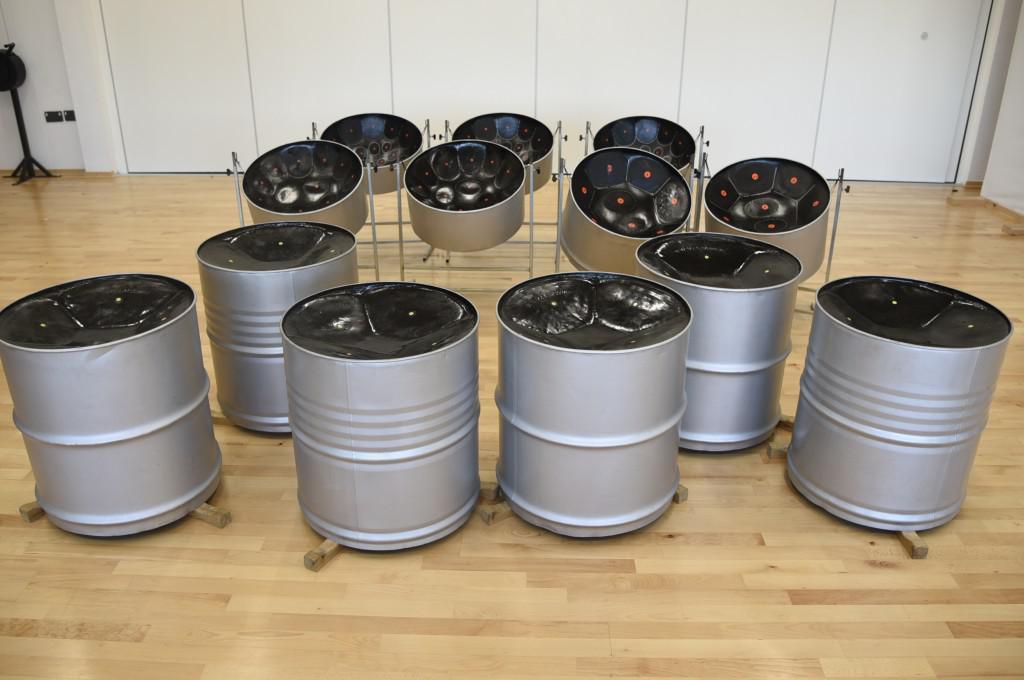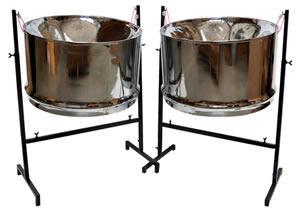The first image is the image on the left, the second image is the image on the right. Given the left and right images, does the statement "One image features a pair of drums wrapped in pale cord, with pillow bases and flat tops with black dots in the center, and the other image is a pair of side-by-side shiny bowl-shaped steel drums." hold true? Answer yes or no. No. The first image is the image on the left, the second image is the image on the right. For the images displayed, is the sentence "a set of drums have a dark circle on top, and leather strips around the drum holding wooden dowels" factually correct? Answer yes or no. No. 